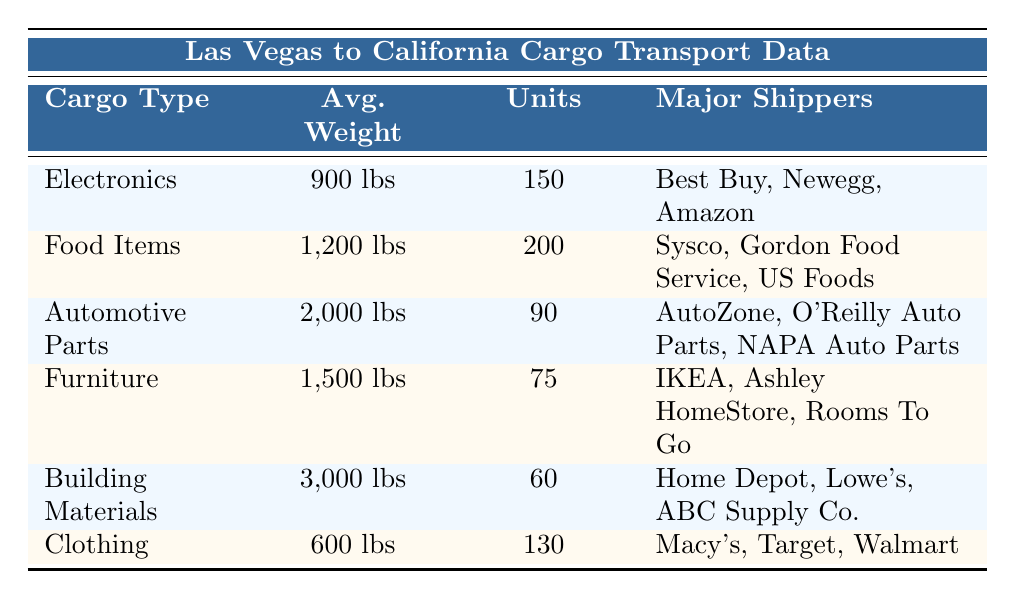What is the average weight of Food Items transported? The table specifies the average weight of Food Items as "1,200 lbs." Therefore, the information can be directly retrieved from the table without requiring further calculation.
Answer: 1,200 lbs Which cargo type is transported in the largest quantity? By examining the "Units" column for each cargo type, Food Items have the highest value at 200 transported units. Thus, it is the largest quantity transported.
Answer: Food Items How much heavier, on average, are Building Materials compared to Clothing? The average weight of Building Materials is 3,000 lbs and Clothing is 600 lbs. To find the difference, we subtract the average weight of Clothing from that of Building Materials: 3,000 lbs - 600 lbs = 2,400 lbs.
Answer: 2,400 lbs Is it true that Electronics have a lower average weight than Furniture? The average weight of Electronics is 900 lbs and that of Furniture is 1,500 lbs. Since 900 lbs is less than 1,500 lbs, the statement is true.
Answer: Yes What is the total average weight of all the cargo types listed? To find the total average weight, we first sum the average weights of all cargo types: 900 lbs + 1,200 lbs + 2,000 lbs + 1,500 lbs + 3,000 lbs + 600 lbs = 9,200 lbs. Next, we divide by the number of cargo types (which is 6): 9,200 lbs / 6 = 1,533.33 lbs. The total average weight is therefore approximately 1,533.33 lbs.
Answer: 1,533.33 lbs 